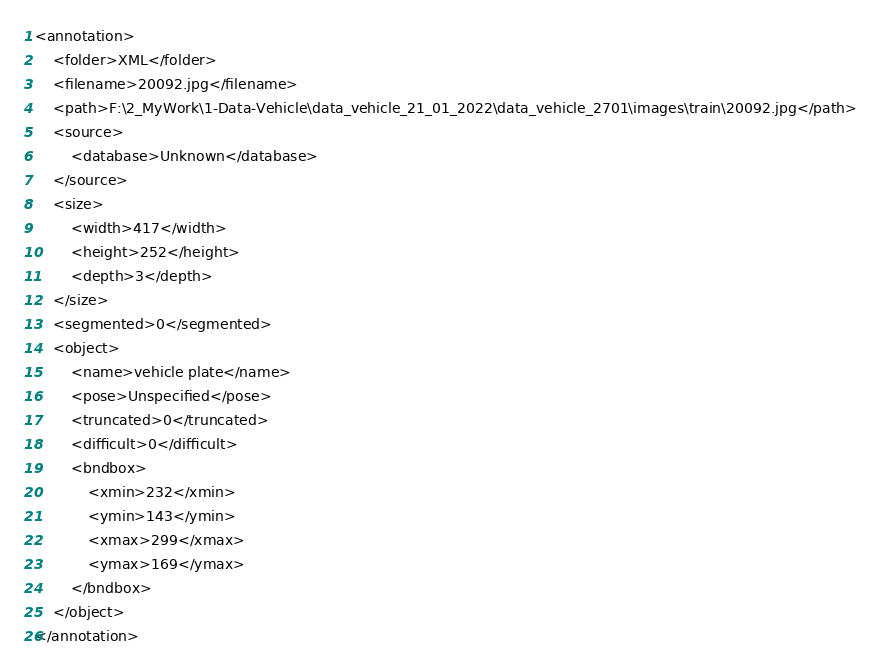Convert code to text. <code><loc_0><loc_0><loc_500><loc_500><_XML_><annotation>
	<folder>XML</folder>
	<filename>20092.jpg</filename>
	<path>F:\2_MyWork\1-Data-Vehicle\data_vehicle_21_01_2022\data_vehicle_2701\images\train\20092.jpg</path>
	<source>
		<database>Unknown</database>
	</source>
	<size>
		<width>417</width>
		<height>252</height>
		<depth>3</depth>
	</size>
	<segmented>0</segmented>
	<object>
		<name>vehicle plate</name>
		<pose>Unspecified</pose>
		<truncated>0</truncated>
		<difficult>0</difficult>
		<bndbox>
			<xmin>232</xmin>
			<ymin>143</ymin>
			<xmax>299</xmax>
			<ymax>169</ymax>
		</bndbox>
	</object>
</annotation>
</code> 